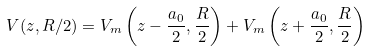<formula> <loc_0><loc_0><loc_500><loc_500>V ( z , R / 2 ) = V _ { m } \left ( z - \frac { a _ { 0 } } { 2 } , \frac { R } { 2 } \right ) + V _ { m } \left ( z + \frac { a _ { 0 } } { 2 } , \frac { R } { 2 } \right )</formula> 